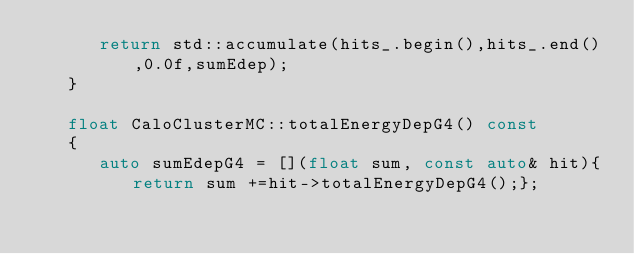Convert code to text. <code><loc_0><loc_0><loc_500><loc_500><_C++_>      return std::accumulate(hits_.begin(),hits_.end(),0.0f,sumEdep);
   }

   float CaloClusterMC::totalEnergyDepG4() const 
   {
      auto sumEdepG4 = [](float sum, const auto& hit){return sum +=hit->totalEnergyDepG4();};</code> 